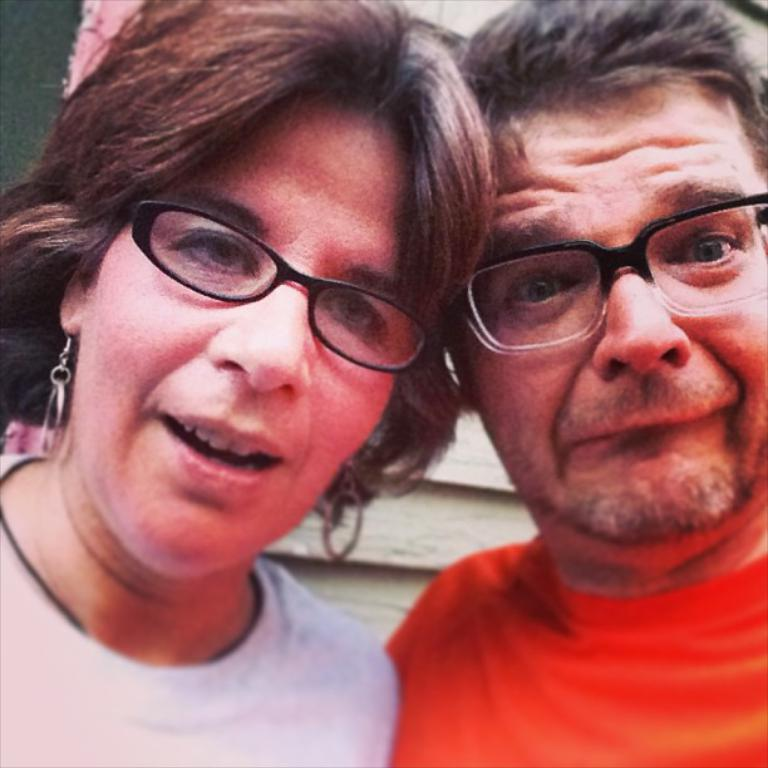How many people are in the image? There are two people in the image, a woman and a man. What are the people in the image doing? Both the woman and the man are standing. What can be seen on the faces of the woman and the man? The woman and the man are wearing spectacles. What is visible in the background of the image? There is a wall in the background of the image. What type of bell can be heard ringing in the image? There is no bell present in the image, and therefore no sound can be heard. 